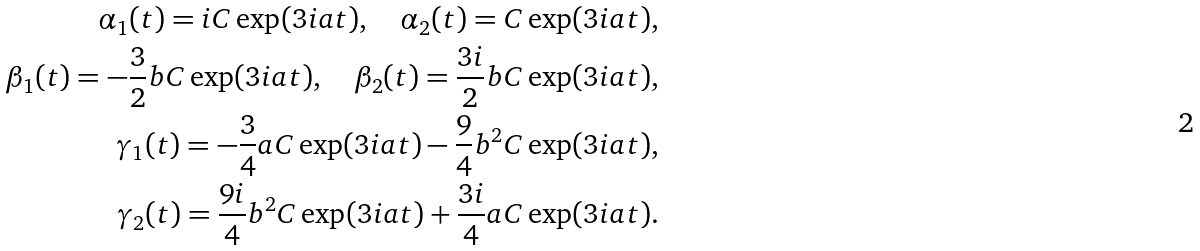Convert formula to latex. <formula><loc_0><loc_0><loc_500><loc_500>\alpha _ { 1 } ( t ) = i C \exp ( 3 i a t ) , \quad \alpha _ { 2 } ( t ) = C \exp ( 3 i a t ) , \\ \beta _ { 1 } ( t ) = - \frac { 3 } { 2 } b C \exp ( 3 i a t ) , \quad \beta _ { 2 } ( t ) = \frac { 3 i } { 2 } b C \exp ( 3 i a t ) , \\ \gamma _ { 1 } ( t ) = - \frac { 3 } { 4 } a C \exp ( 3 i a t ) - \frac { 9 } { 4 } b ^ { 2 } C \exp ( 3 i a t ) , \\ \gamma _ { 2 } ( t ) = \frac { 9 i } { 4 } b ^ { 2 } C \exp ( 3 i a t ) + \frac { 3 i } { 4 } a C \exp ( 3 i a t ) .</formula> 